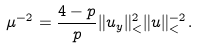Convert formula to latex. <formula><loc_0><loc_0><loc_500><loc_500>\mu ^ { - 2 } = \frac { 4 - p } { p } \| u _ { y } \| _ { < } ^ { 2 } \| u \| _ { < } ^ { - 2 } .</formula> 